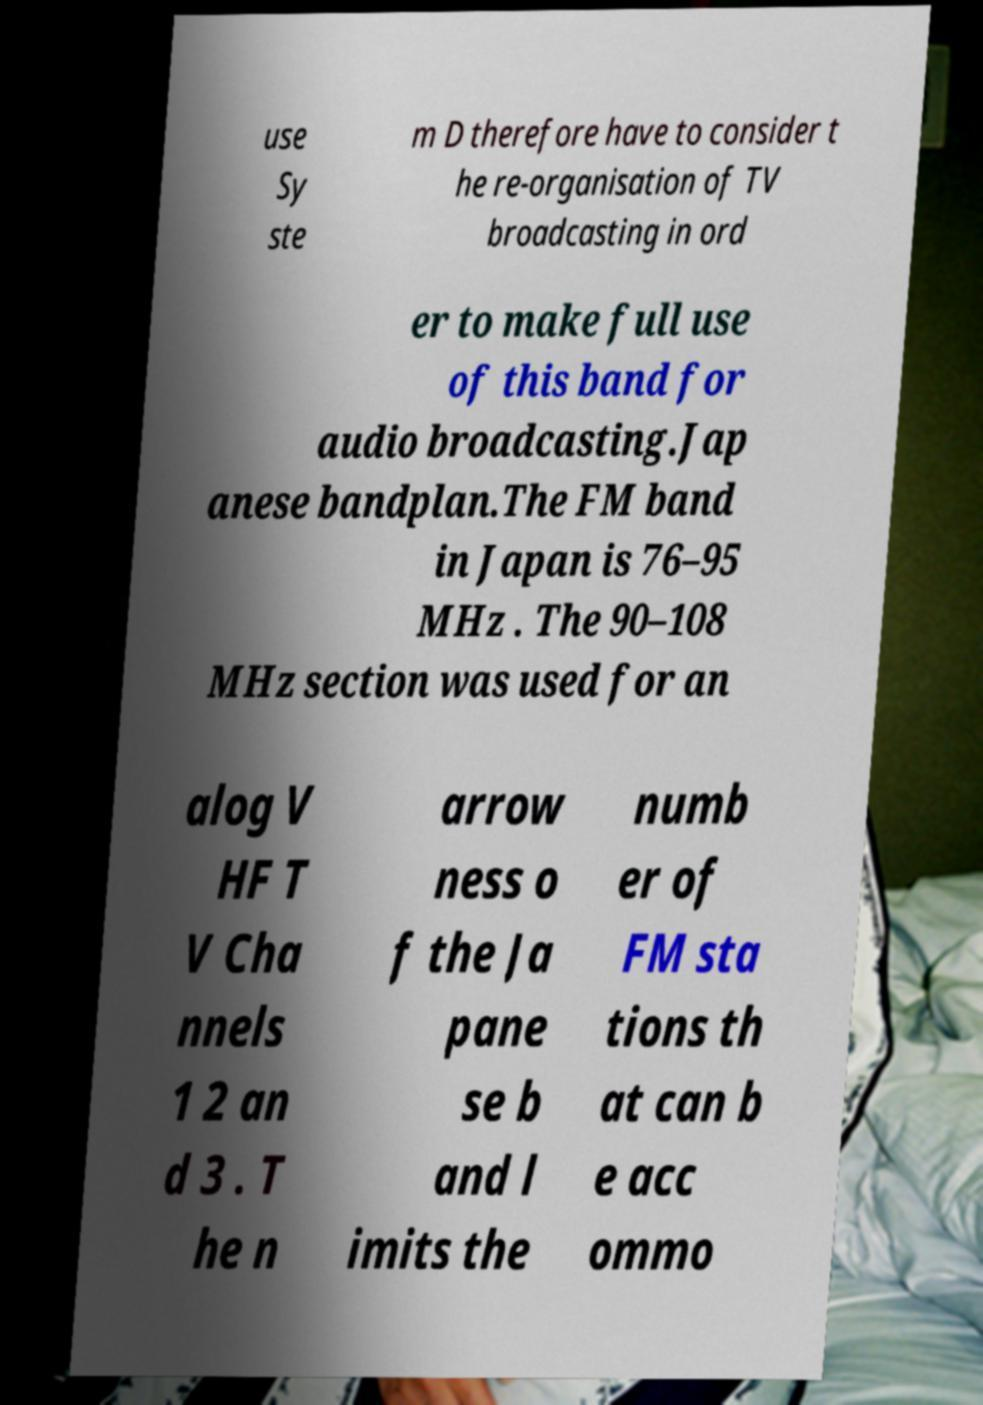Could you assist in decoding the text presented in this image and type it out clearly? use Sy ste m D therefore have to consider t he re-organisation of TV broadcasting in ord er to make full use of this band for audio broadcasting.Jap anese bandplan.The FM band in Japan is 76–95 MHz . The 90–108 MHz section was used for an alog V HF T V Cha nnels 1 2 an d 3 . T he n arrow ness o f the Ja pane se b and l imits the numb er of FM sta tions th at can b e acc ommo 